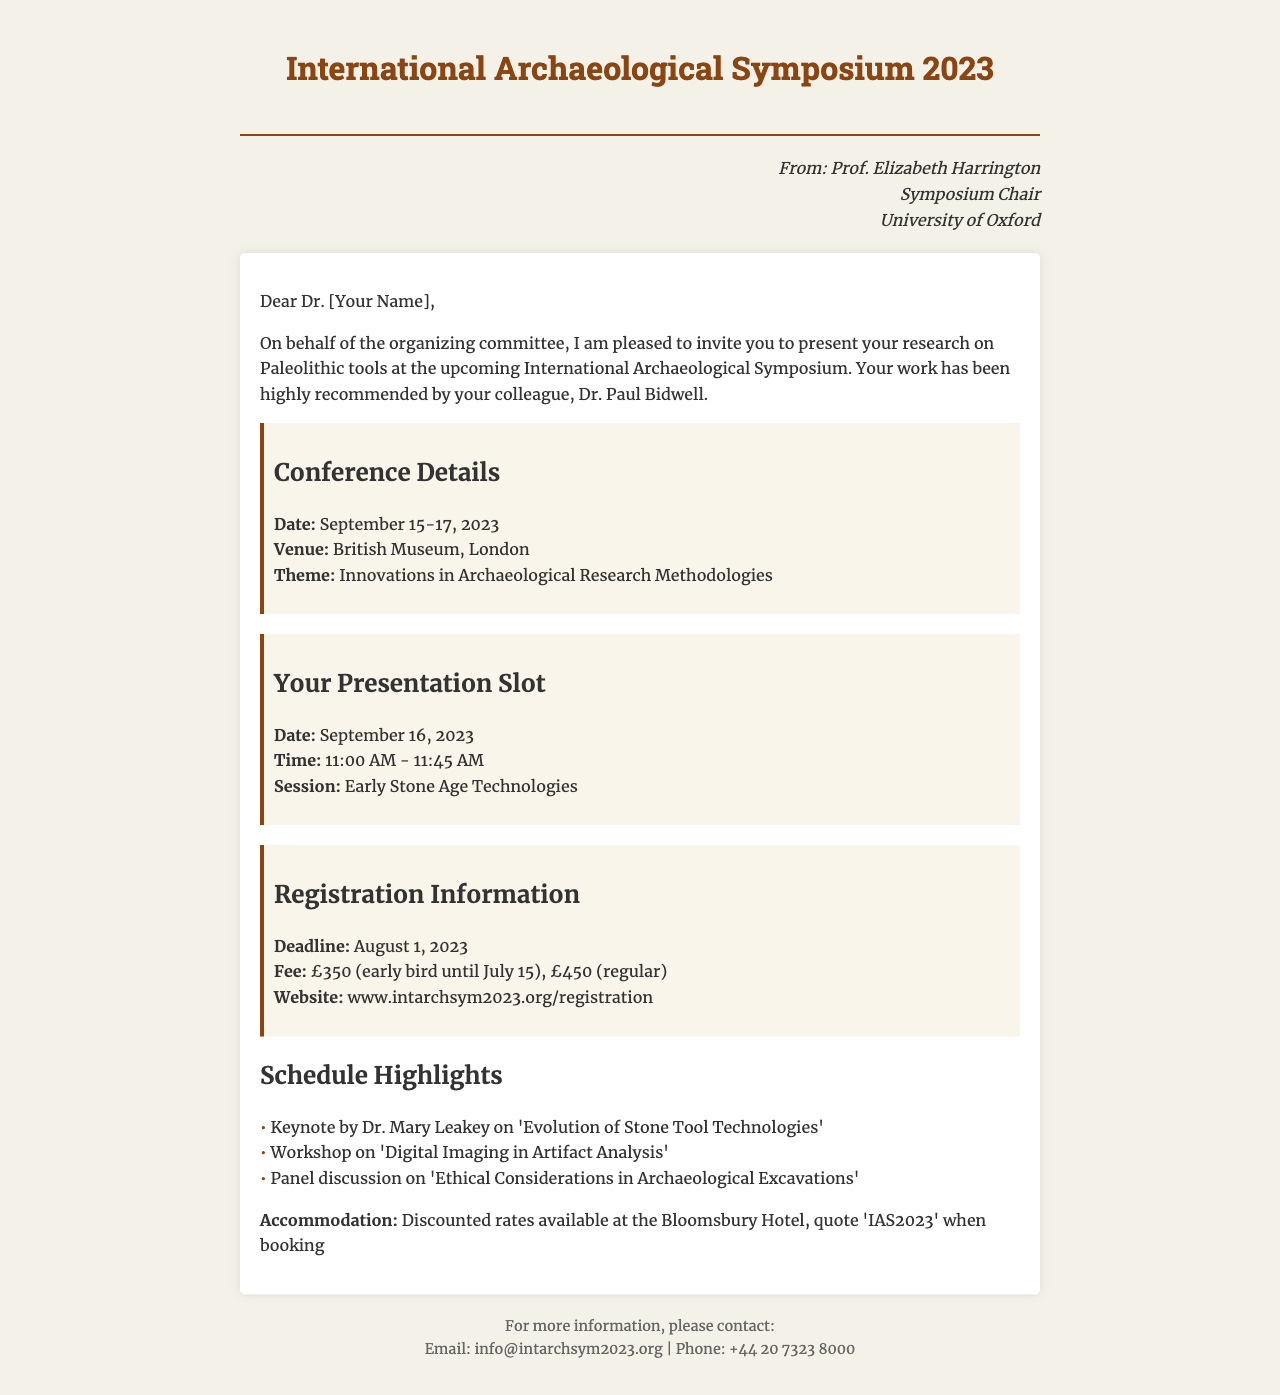What is the date of the conference? The date of the conference is mentioned in the conference details section, which states it is on September 15-17, 2023.
Answer: September 15-17, 2023 Who is the Symposium Chair? The document specifies that the Symposium Chair is Prof. Elizabeth Harrington.
Answer: Prof. Elizabeth Harrington What is the early bird registration fee? The early bird registration fee is provided in the registration information section, stating £350 until July 15.
Answer: £350 What time is your presentation scheduled for? The presentation slot section indicates that the presentation is at 11:00 AM - 11:45 AM on September 16, 2023.
Answer: 11:00 AM - 11:45 AM What is the theme of the symposium? The theme of the symposium is mentioned under the conference details as "Innovations in Archaeological Research Methodologies."
Answer: Innovations in Archaeological Research Methodologies Who will give the keynote address? The schedule highlights a keynote by Dr. Mary Leakey, focusing on 'Evolution of Stone Tool Technologies.'
Answer: Dr. Mary Leakey What is the registration deadline? The registration deadline is clearly stated in the registration information as August 1, 2023.
Answer: August 1, 2023 What is the venue of the conference? The venue for the conference is provided in the conference details section as the British Museum, London.
Answer: British Museum, London What accommodation discount code is mentioned? The document mentions a discount code 'IAS2023' for booking at the Bloomsbury Hotel.
Answer: IAS2023 